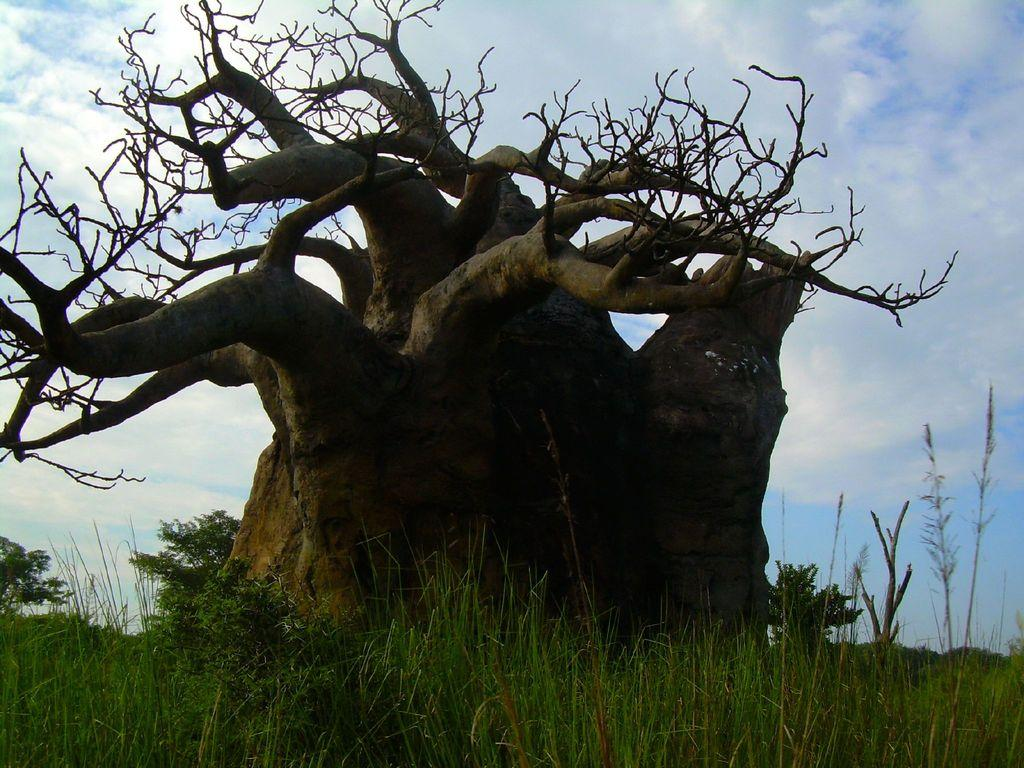What is the main subject in the image? There is a tree in the image. Where is the tree located? The tree is in the middle of a grassland. What can be seen in the background of the image? The sky is visible in the image. What is the condition of the sky in the image? Clouds are present in the sky. What type of discussion is taking place near the tree in the image? There is no discussion taking place near the tree in the image. Can you see any goats grazing in the grassland around the tree? There are no goats present in the image. 